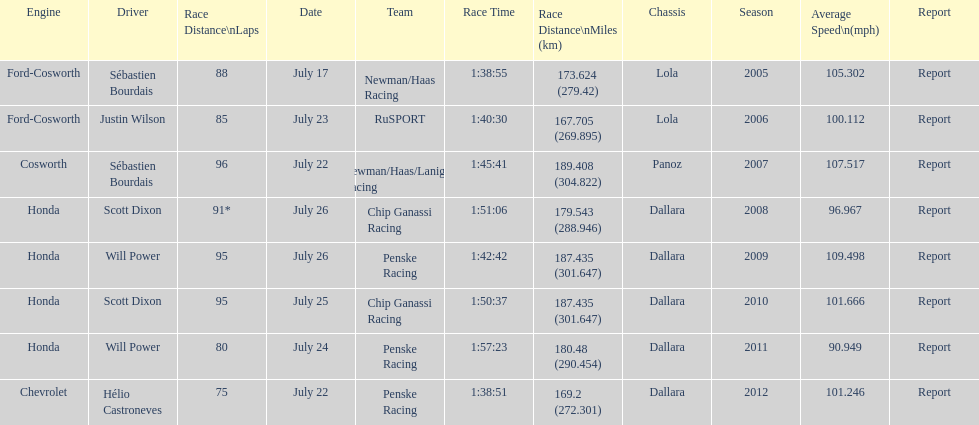How many flags other than france (the first flag) are represented? 3. 